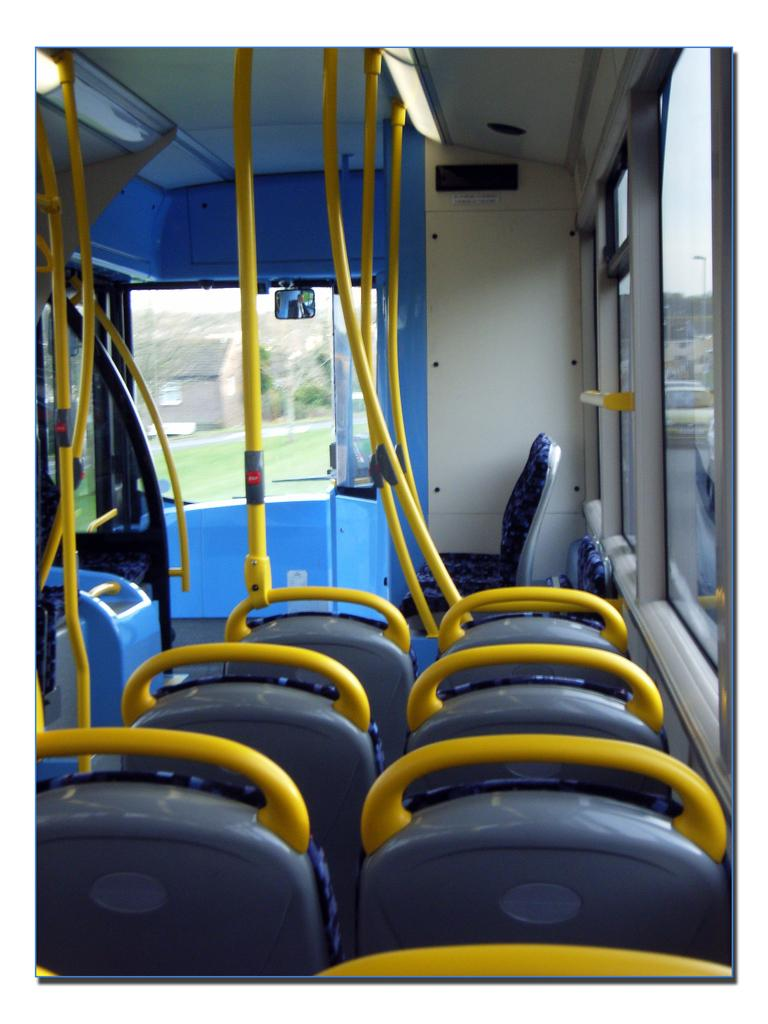What type of space is depicted in the image? The image shows the interior of a vehicle. What can be found inside the vehicle? There are seats and yellow poles in the vehicle. What material is used for the windows in the vehicle? The windows in the vehicle are made of glass. What can be seen outside the vehicle in the background? Trees are visible in the background of the image. What type of house is visible in the image? There is no house visible in the image; it shows the interior of a vehicle with trees in the background. What kind of club can be seen in the image? There is no club present in the image; it shows the interior of a vehicle with trees in the background. 